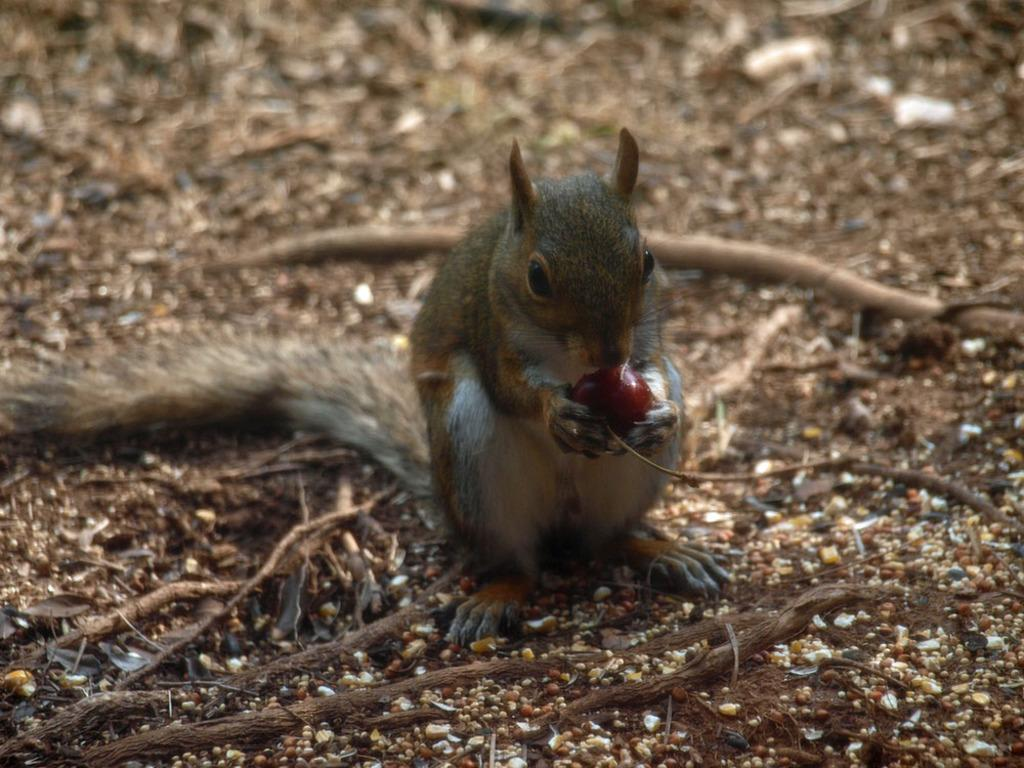What animal can be seen in the image? There is a squirrel in the image. What is the squirrel doing in the image? The squirrel is eating fruit in the image. What type of terrain is visible in the image? There is sand and small stones in the image, along with visible roots. Who is the secretary in the image? There is no secretary present in the image; it features a squirrel eating fruit in a sandy environment with small stones and visible roots. 